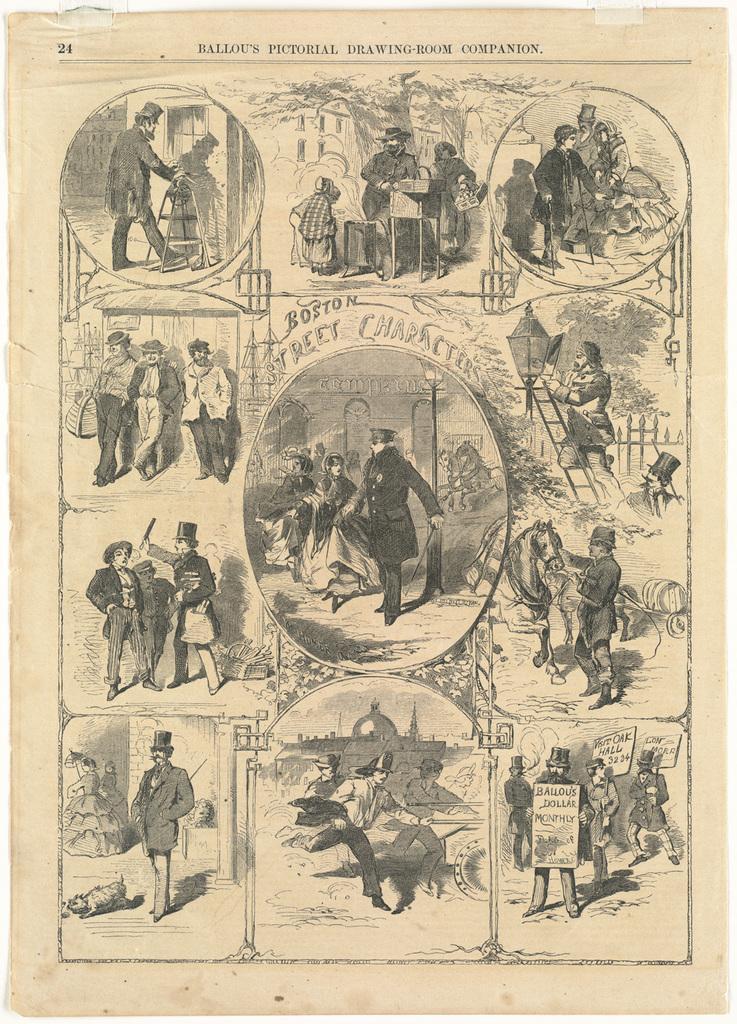In one or two sentences, can you explain what this image depicts? In this picture I can see there are a few images of the few persons standing, walking, holding a horse, holding banners. There are few trees and buildings, there is something written at the top of the image. 